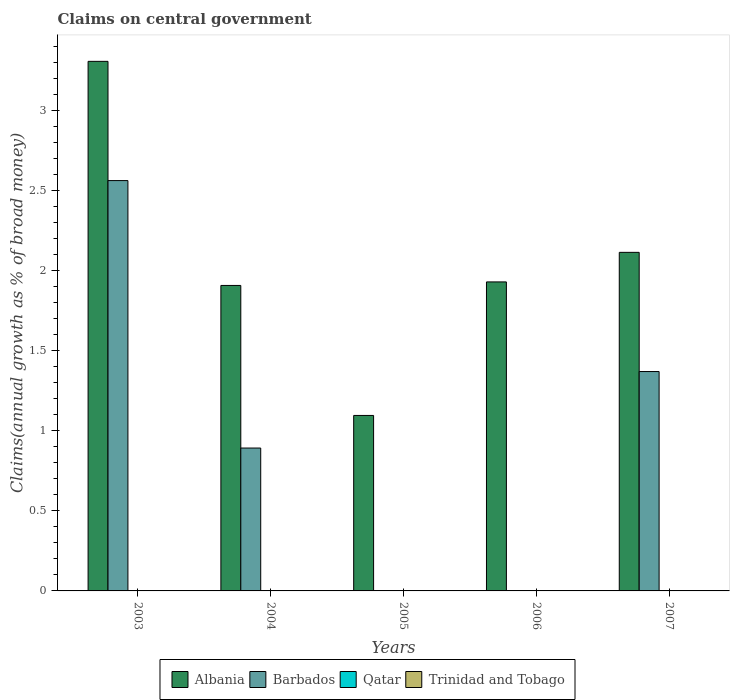How many different coloured bars are there?
Provide a succinct answer. 2. Are the number of bars per tick equal to the number of legend labels?
Offer a very short reply. No. How many bars are there on the 2nd tick from the left?
Provide a short and direct response. 2. What is the label of the 4th group of bars from the left?
Your response must be concise. 2006. What is the percentage of broad money claimed on centeral government in Albania in 2007?
Keep it short and to the point. 2.11. Across all years, what is the maximum percentage of broad money claimed on centeral government in Albania?
Make the answer very short. 3.3. Across all years, what is the minimum percentage of broad money claimed on centeral government in Qatar?
Your response must be concise. 0. In which year was the percentage of broad money claimed on centeral government in Albania maximum?
Make the answer very short. 2003. What is the total percentage of broad money claimed on centeral government in Albania in the graph?
Ensure brevity in your answer.  10.35. What is the difference between the percentage of broad money claimed on centeral government in Albania in 2006 and that in 2007?
Provide a short and direct response. -0.18. What is the difference between the percentage of broad money claimed on centeral government in Albania in 2007 and the percentage of broad money claimed on centeral government in Barbados in 2004?
Your answer should be compact. 1.22. What is the average percentage of broad money claimed on centeral government in Barbados per year?
Offer a terse response. 0.96. In how many years, is the percentage of broad money claimed on centeral government in Albania greater than 1 %?
Your response must be concise. 5. What is the ratio of the percentage of broad money claimed on centeral government in Albania in 2006 to that in 2007?
Your answer should be compact. 0.91. Is the percentage of broad money claimed on centeral government in Barbados in 2004 less than that in 2007?
Ensure brevity in your answer.  Yes. What is the difference between the highest and the second highest percentage of broad money claimed on centeral government in Albania?
Your response must be concise. 1.19. What is the difference between the highest and the lowest percentage of broad money claimed on centeral government in Barbados?
Your answer should be compact. 2.56. Does the graph contain grids?
Your answer should be very brief. No. What is the title of the graph?
Keep it short and to the point. Claims on central government. What is the label or title of the X-axis?
Offer a very short reply. Years. What is the label or title of the Y-axis?
Ensure brevity in your answer.  Claims(annual growth as % of broad money). What is the Claims(annual growth as % of broad money) of Albania in 2003?
Your answer should be very brief. 3.3. What is the Claims(annual growth as % of broad money) in Barbados in 2003?
Offer a very short reply. 2.56. What is the Claims(annual growth as % of broad money) in Albania in 2004?
Provide a short and direct response. 1.91. What is the Claims(annual growth as % of broad money) of Barbados in 2004?
Offer a terse response. 0.89. What is the Claims(annual growth as % of broad money) of Qatar in 2004?
Make the answer very short. 0. What is the Claims(annual growth as % of broad money) of Albania in 2005?
Your answer should be very brief. 1.09. What is the Claims(annual growth as % of broad money) of Barbados in 2005?
Offer a very short reply. 0. What is the Claims(annual growth as % of broad money) of Qatar in 2005?
Make the answer very short. 0. What is the Claims(annual growth as % of broad money) of Albania in 2006?
Keep it short and to the point. 1.93. What is the Claims(annual growth as % of broad money) in Barbados in 2006?
Provide a succinct answer. 0. What is the Claims(annual growth as % of broad money) in Qatar in 2006?
Give a very brief answer. 0. What is the Claims(annual growth as % of broad money) of Trinidad and Tobago in 2006?
Ensure brevity in your answer.  0. What is the Claims(annual growth as % of broad money) of Albania in 2007?
Offer a very short reply. 2.11. What is the Claims(annual growth as % of broad money) of Barbados in 2007?
Give a very brief answer. 1.37. Across all years, what is the maximum Claims(annual growth as % of broad money) of Albania?
Make the answer very short. 3.3. Across all years, what is the maximum Claims(annual growth as % of broad money) in Barbados?
Ensure brevity in your answer.  2.56. Across all years, what is the minimum Claims(annual growth as % of broad money) in Albania?
Provide a succinct answer. 1.09. Across all years, what is the minimum Claims(annual growth as % of broad money) of Barbados?
Provide a short and direct response. 0. What is the total Claims(annual growth as % of broad money) in Albania in the graph?
Your answer should be compact. 10.35. What is the total Claims(annual growth as % of broad money) in Barbados in the graph?
Give a very brief answer. 4.82. What is the total Claims(annual growth as % of broad money) of Qatar in the graph?
Provide a succinct answer. 0. What is the difference between the Claims(annual growth as % of broad money) of Albania in 2003 and that in 2004?
Your response must be concise. 1.4. What is the difference between the Claims(annual growth as % of broad money) in Barbados in 2003 and that in 2004?
Give a very brief answer. 1.67. What is the difference between the Claims(annual growth as % of broad money) in Albania in 2003 and that in 2005?
Offer a very short reply. 2.21. What is the difference between the Claims(annual growth as % of broad money) in Albania in 2003 and that in 2006?
Offer a terse response. 1.38. What is the difference between the Claims(annual growth as % of broad money) in Albania in 2003 and that in 2007?
Keep it short and to the point. 1.19. What is the difference between the Claims(annual growth as % of broad money) of Barbados in 2003 and that in 2007?
Provide a short and direct response. 1.19. What is the difference between the Claims(annual growth as % of broad money) of Albania in 2004 and that in 2005?
Your answer should be compact. 0.81. What is the difference between the Claims(annual growth as % of broad money) of Albania in 2004 and that in 2006?
Provide a short and direct response. -0.02. What is the difference between the Claims(annual growth as % of broad money) in Albania in 2004 and that in 2007?
Your response must be concise. -0.21. What is the difference between the Claims(annual growth as % of broad money) of Barbados in 2004 and that in 2007?
Ensure brevity in your answer.  -0.48. What is the difference between the Claims(annual growth as % of broad money) in Albania in 2005 and that in 2006?
Make the answer very short. -0.83. What is the difference between the Claims(annual growth as % of broad money) in Albania in 2005 and that in 2007?
Offer a very short reply. -1.02. What is the difference between the Claims(annual growth as % of broad money) of Albania in 2006 and that in 2007?
Make the answer very short. -0.18. What is the difference between the Claims(annual growth as % of broad money) in Albania in 2003 and the Claims(annual growth as % of broad money) in Barbados in 2004?
Ensure brevity in your answer.  2.41. What is the difference between the Claims(annual growth as % of broad money) of Albania in 2003 and the Claims(annual growth as % of broad money) of Barbados in 2007?
Give a very brief answer. 1.94. What is the difference between the Claims(annual growth as % of broad money) of Albania in 2004 and the Claims(annual growth as % of broad money) of Barbados in 2007?
Your response must be concise. 0.54. What is the difference between the Claims(annual growth as % of broad money) of Albania in 2005 and the Claims(annual growth as % of broad money) of Barbados in 2007?
Your answer should be compact. -0.27. What is the difference between the Claims(annual growth as % of broad money) in Albania in 2006 and the Claims(annual growth as % of broad money) in Barbados in 2007?
Your answer should be very brief. 0.56. What is the average Claims(annual growth as % of broad money) of Albania per year?
Your response must be concise. 2.07. What is the average Claims(annual growth as % of broad money) of Barbados per year?
Provide a short and direct response. 0.96. What is the average Claims(annual growth as % of broad money) in Qatar per year?
Provide a short and direct response. 0. What is the average Claims(annual growth as % of broad money) in Trinidad and Tobago per year?
Offer a terse response. 0. In the year 2003, what is the difference between the Claims(annual growth as % of broad money) of Albania and Claims(annual growth as % of broad money) of Barbados?
Your answer should be compact. 0.74. In the year 2004, what is the difference between the Claims(annual growth as % of broad money) of Albania and Claims(annual growth as % of broad money) of Barbados?
Offer a terse response. 1.01. In the year 2007, what is the difference between the Claims(annual growth as % of broad money) of Albania and Claims(annual growth as % of broad money) of Barbados?
Your answer should be very brief. 0.74. What is the ratio of the Claims(annual growth as % of broad money) of Albania in 2003 to that in 2004?
Give a very brief answer. 1.73. What is the ratio of the Claims(annual growth as % of broad money) of Barbados in 2003 to that in 2004?
Make the answer very short. 2.87. What is the ratio of the Claims(annual growth as % of broad money) of Albania in 2003 to that in 2005?
Provide a short and direct response. 3.02. What is the ratio of the Claims(annual growth as % of broad money) of Albania in 2003 to that in 2006?
Make the answer very short. 1.71. What is the ratio of the Claims(annual growth as % of broad money) of Albania in 2003 to that in 2007?
Provide a succinct answer. 1.56. What is the ratio of the Claims(annual growth as % of broad money) of Barbados in 2003 to that in 2007?
Give a very brief answer. 1.87. What is the ratio of the Claims(annual growth as % of broad money) in Albania in 2004 to that in 2005?
Make the answer very short. 1.74. What is the ratio of the Claims(annual growth as % of broad money) in Albania in 2004 to that in 2006?
Your answer should be very brief. 0.99. What is the ratio of the Claims(annual growth as % of broad money) in Albania in 2004 to that in 2007?
Your answer should be compact. 0.9. What is the ratio of the Claims(annual growth as % of broad money) in Barbados in 2004 to that in 2007?
Provide a short and direct response. 0.65. What is the ratio of the Claims(annual growth as % of broad money) in Albania in 2005 to that in 2006?
Offer a terse response. 0.57. What is the ratio of the Claims(annual growth as % of broad money) in Albania in 2005 to that in 2007?
Make the answer very short. 0.52. What is the ratio of the Claims(annual growth as % of broad money) in Albania in 2006 to that in 2007?
Provide a succinct answer. 0.91. What is the difference between the highest and the second highest Claims(annual growth as % of broad money) in Albania?
Offer a very short reply. 1.19. What is the difference between the highest and the second highest Claims(annual growth as % of broad money) of Barbados?
Offer a terse response. 1.19. What is the difference between the highest and the lowest Claims(annual growth as % of broad money) of Albania?
Your response must be concise. 2.21. What is the difference between the highest and the lowest Claims(annual growth as % of broad money) of Barbados?
Provide a short and direct response. 2.56. 